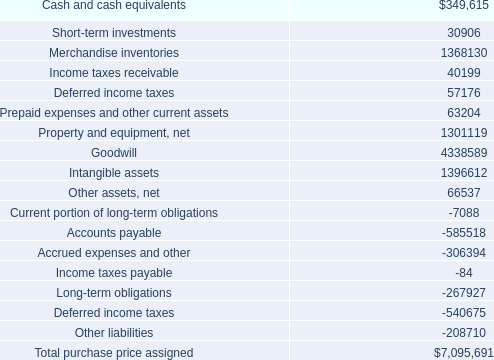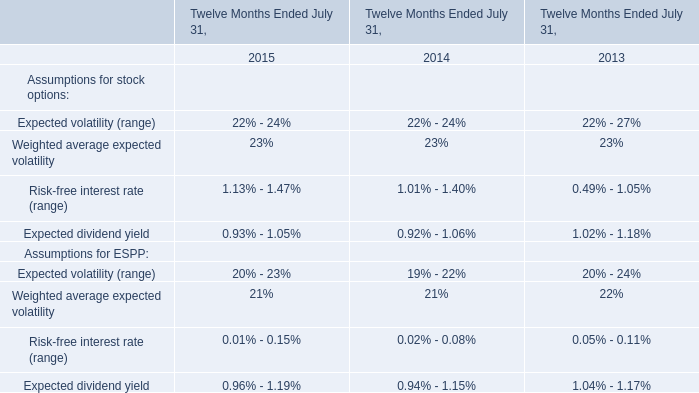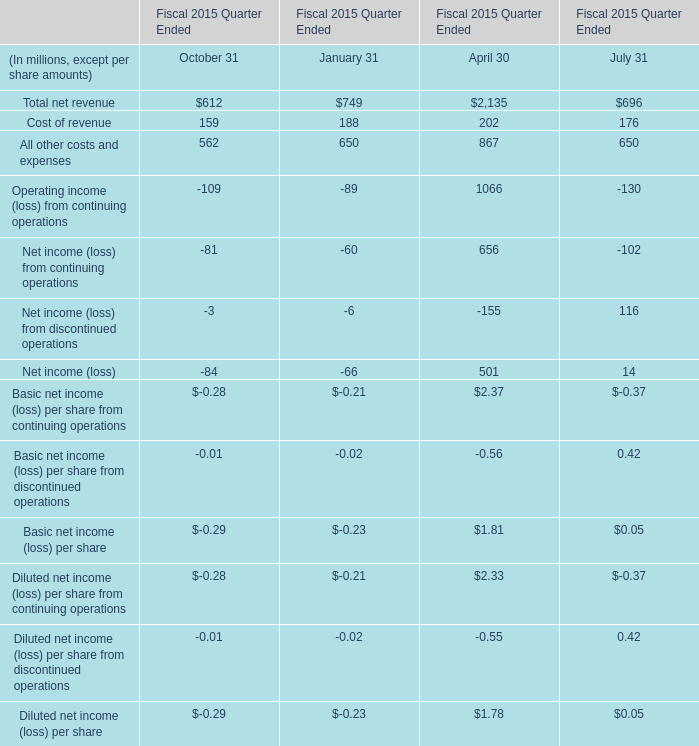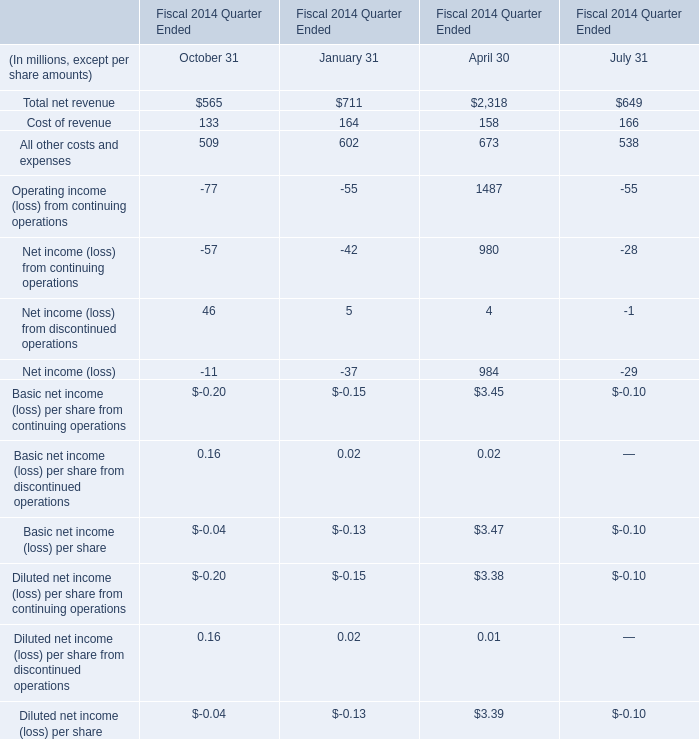How many kinds of October 31 are greater than 0 in 2015? 
Answer: 3. 